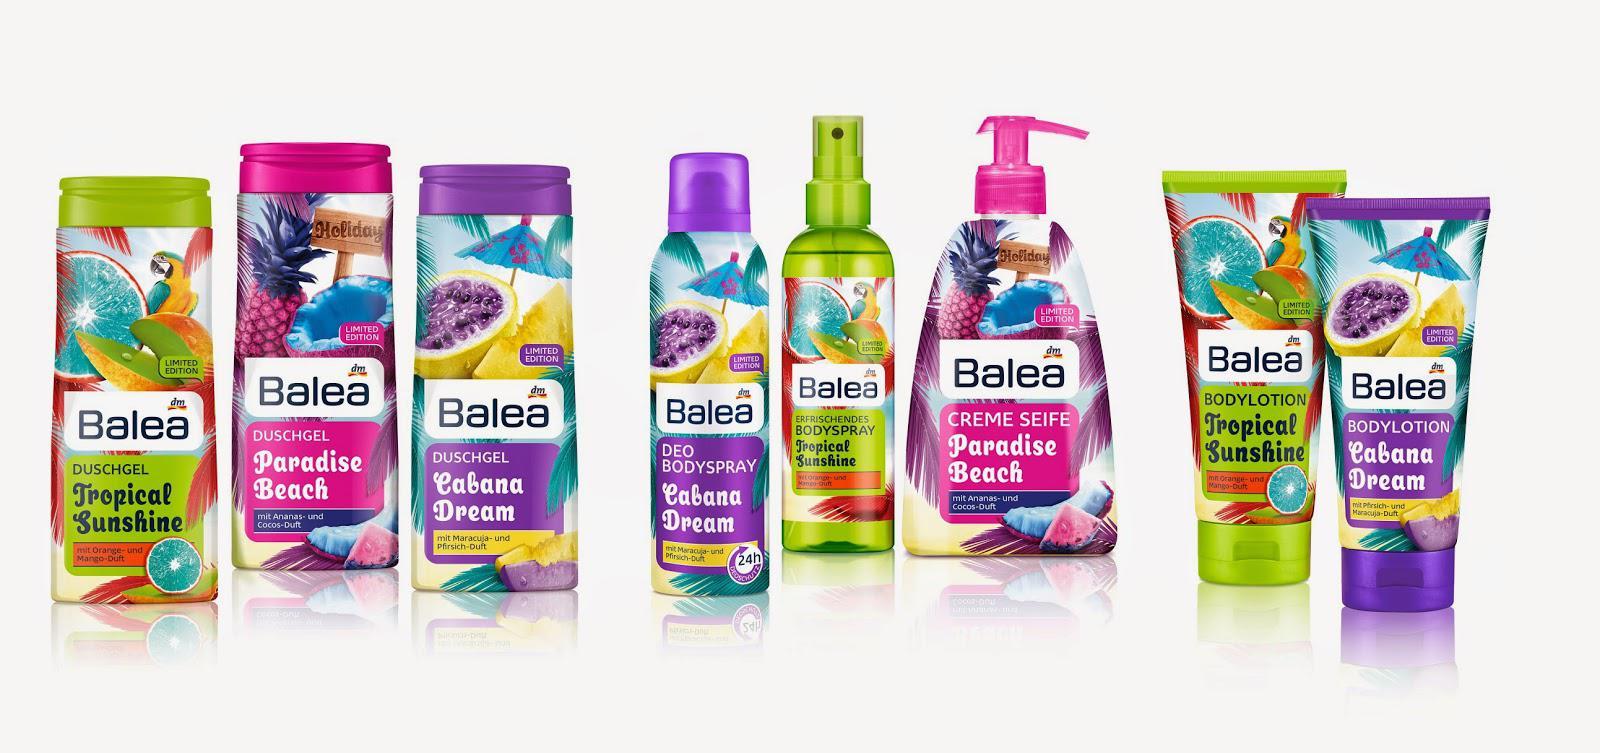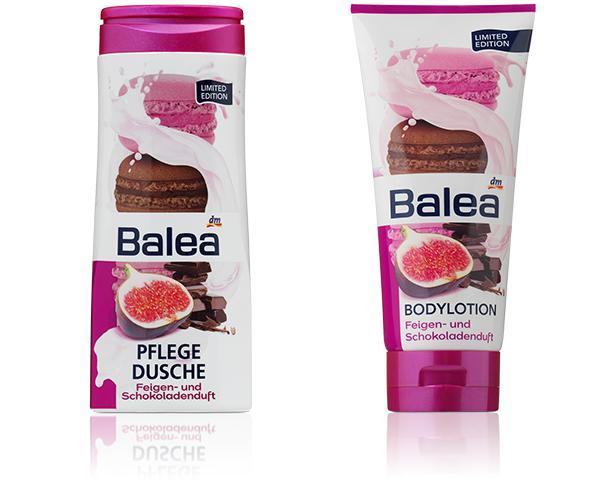The first image is the image on the left, the second image is the image on the right. Assess this claim about the two images: "The image on the right contains both a blue and a red circular container.". Correct or not? Answer yes or no. No. 